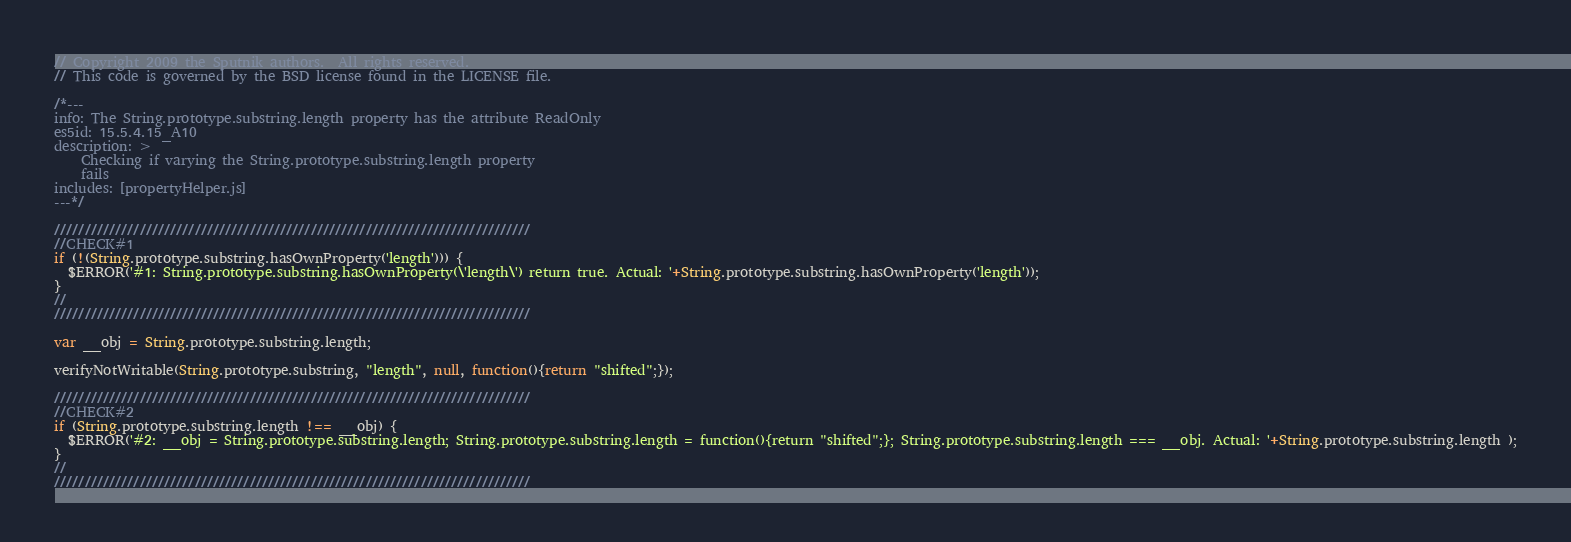<code> <loc_0><loc_0><loc_500><loc_500><_JavaScript_>// Copyright 2009 the Sputnik authors.  All rights reserved.
// This code is governed by the BSD license found in the LICENSE file.

/*---
info: The String.prototype.substring.length property has the attribute ReadOnly
es5id: 15.5.4.15_A10
description: >
    Checking if varying the String.prototype.substring.length property
    fails
includes: [propertyHelper.js]
---*/

//////////////////////////////////////////////////////////////////////////////
//CHECK#1
if (!(String.prototype.substring.hasOwnProperty('length'))) {
  $ERROR('#1: String.prototype.substring.hasOwnProperty(\'length\') return true. Actual: '+String.prototype.substring.hasOwnProperty('length'));
}
//
//////////////////////////////////////////////////////////////////////////////

var __obj = String.prototype.substring.length;

verifyNotWritable(String.prototype.substring, "length", null, function(){return "shifted";});

//////////////////////////////////////////////////////////////////////////////
//CHECK#2
if (String.prototype.substring.length !== __obj) {
  $ERROR('#2: __obj = String.prototype.substring.length; String.prototype.substring.length = function(){return "shifted";}; String.prototype.substring.length === __obj. Actual: '+String.prototype.substring.length );
}
//
//////////////////////////////////////////////////////////////////////////////
</code> 